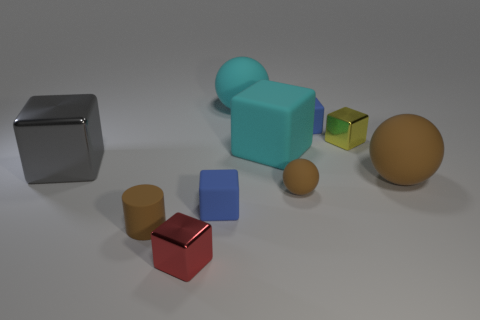Is the material of the red block the same as the gray block in front of the large matte cube? Upon closer examination, both the red and gray blocks appear to have a similar type of surface that reflects light in a consistent manner, suggesting they are made of the same material, which could be a type of matte painted metal or plastic. 